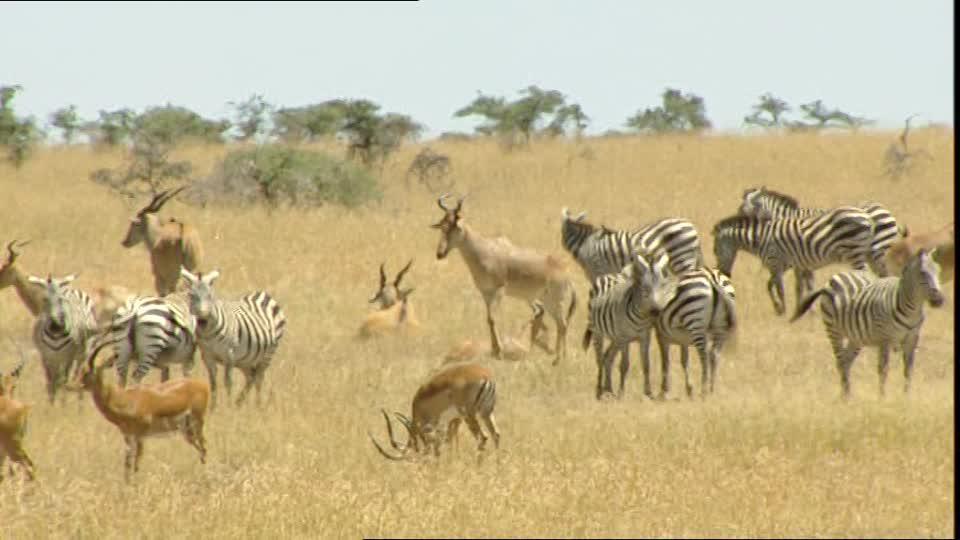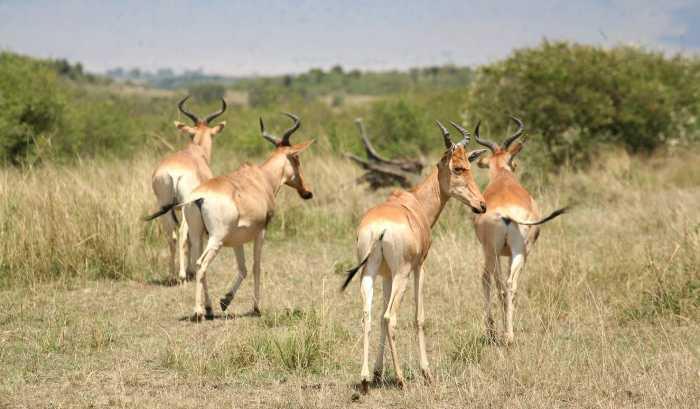The first image is the image on the left, the second image is the image on the right. For the images displayed, is the sentence "Just one hunter crouches behind a downed antelope in one of the images." factually correct? Answer yes or no. No. The first image is the image on the left, the second image is the image on the right. Given the left and right images, does the statement "One of the images contains one man with a dead antelope." hold true? Answer yes or no. No. 